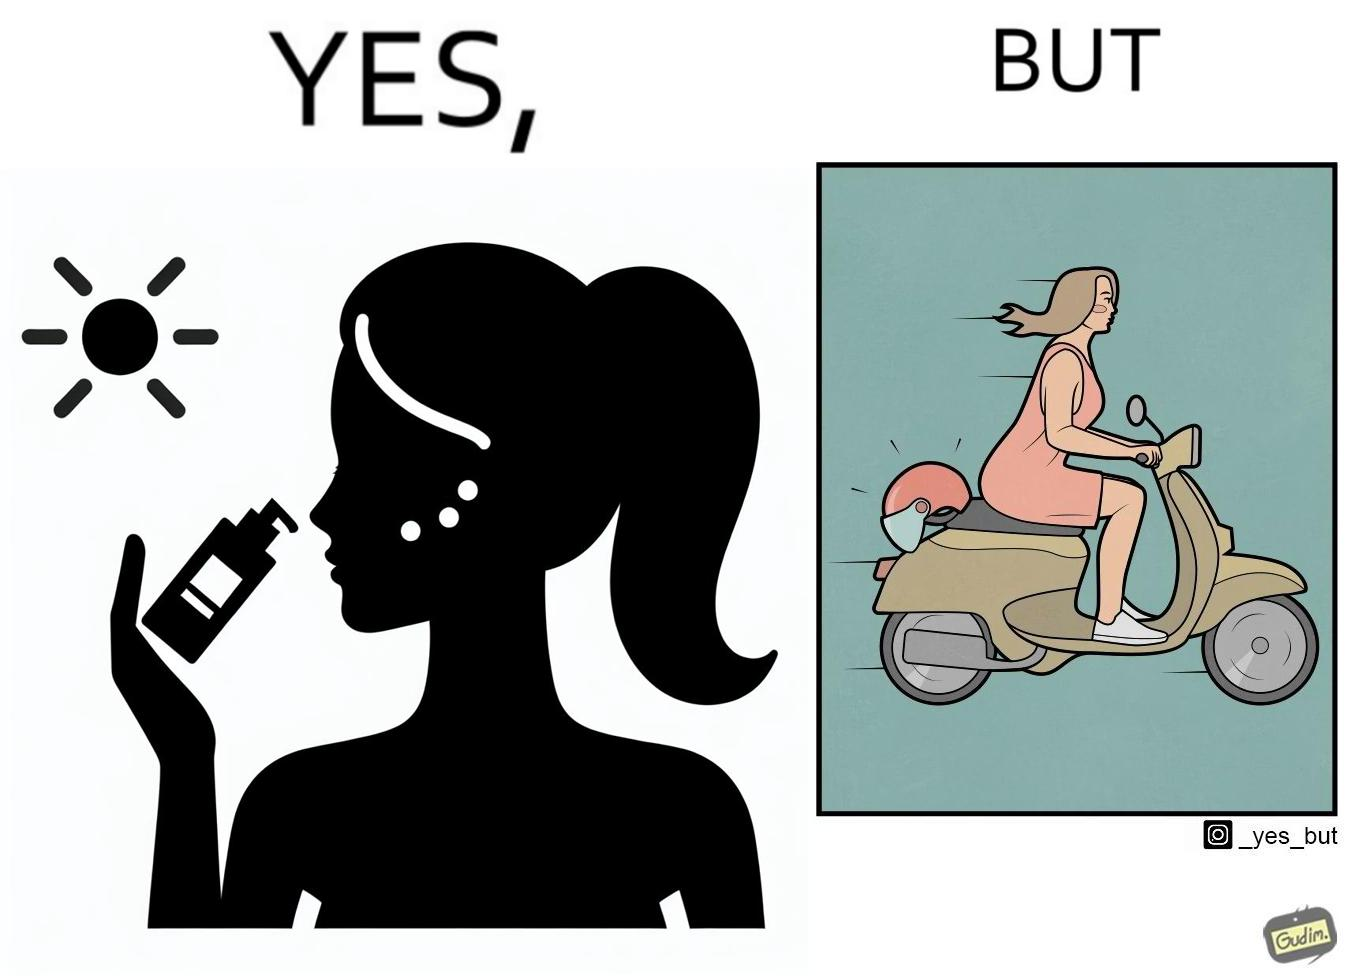Describe the contrast between the left and right parts of this image. In the left part of the image: The image shows a woman applying sunscreen with high SPF on her face. In the right part of the image: The image shows a woman riding a scooter with her helmet on the back seat. 